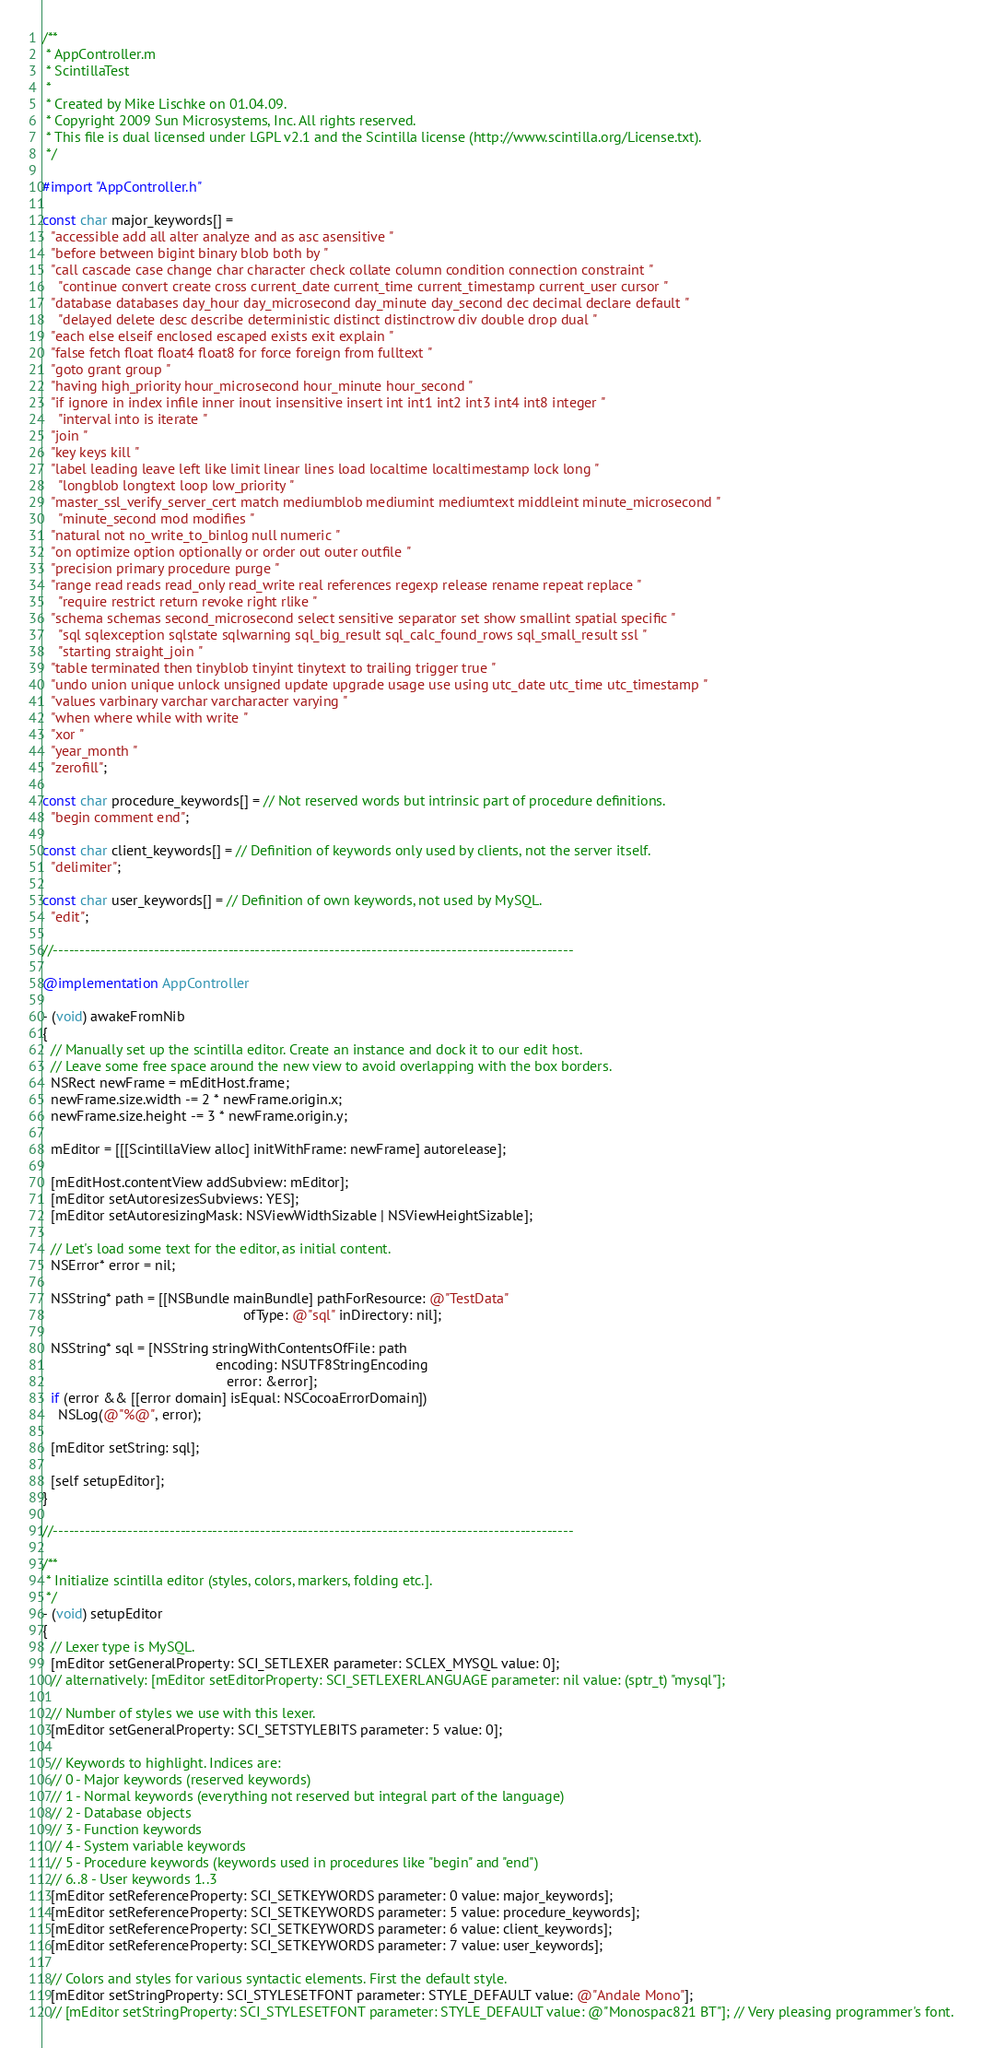Convert code to text. <code><loc_0><loc_0><loc_500><loc_500><_ObjectiveC_>/**
 * AppController.m
 * ScintillaTest
 *
 * Created by Mike Lischke on 01.04.09.
 * Copyright 2009 Sun Microsystems, Inc. All rights reserved.
 * This file is dual licensed under LGPL v2.1 and the Scintilla license (http://www.scintilla.org/License.txt).
 */

#import "AppController.h"

const char major_keywords[] =
  "accessible add all alter analyze and as asc asensitive "
  "before between bigint binary blob both by "
  "call cascade case change char character check collate column condition connection constraint "
    "continue convert create cross current_date current_time current_timestamp current_user cursor "
  "database databases day_hour day_microsecond day_minute day_second dec decimal declare default "
    "delayed delete desc describe deterministic distinct distinctrow div double drop dual "
  "each else elseif enclosed escaped exists exit explain "
  "false fetch float float4 float8 for force foreign from fulltext "
  "goto grant group "
  "having high_priority hour_microsecond hour_minute hour_second "
  "if ignore in index infile inner inout insensitive insert int int1 int2 int3 int4 int8 integer "
    "interval into is iterate "
  "join "
  "key keys kill "
  "label leading leave left like limit linear lines load localtime localtimestamp lock long "
    "longblob longtext loop low_priority "
  "master_ssl_verify_server_cert match mediumblob mediumint mediumtext middleint minute_microsecond "
    "minute_second mod modifies "
  "natural not no_write_to_binlog null numeric "
  "on optimize option optionally or order out outer outfile "
  "precision primary procedure purge "
  "range read reads read_only read_write real references regexp release rename repeat replace "
    "require restrict return revoke right rlike "
  "schema schemas second_microsecond select sensitive separator set show smallint spatial specific "
    "sql sqlexception sqlstate sqlwarning sql_big_result sql_calc_found_rows sql_small_result ssl "
    "starting straight_join "
  "table terminated then tinyblob tinyint tinytext to trailing trigger true "
  "undo union unique unlock unsigned update upgrade usage use using utc_date utc_time utc_timestamp "
  "values varbinary varchar varcharacter varying "
  "when where while with write "
  "xor "
  "year_month "
  "zerofill";

const char procedure_keywords[] = // Not reserved words but intrinsic part of procedure definitions.
  "begin comment end";

const char client_keywords[] = // Definition of keywords only used by clients, not the server itself.
  "delimiter";

const char user_keywords[] = // Definition of own keywords, not used by MySQL.
  "edit";

//--------------------------------------------------------------------------------------------------

@implementation AppController

- (void) awakeFromNib
{
  // Manually set up the scintilla editor. Create an instance and dock it to our edit host.
  // Leave some free space around the new view to avoid overlapping with the box borders.
  NSRect newFrame = mEditHost.frame;
  newFrame.size.width -= 2 * newFrame.origin.x;
  newFrame.size.height -= 3 * newFrame.origin.y;
  
  mEditor = [[[ScintillaView alloc] initWithFrame: newFrame] autorelease];
  
  [mEditHost.contentView addSubview: mEditor];
  [mEditor setAutoresizesSubviews: YES];
  [mEditor setAutoresizingMask: NSViewWidthSizable | NSViewHeightSizable];
  
  // Let's load some text for the editor, as initial content.
  NSError* error = nil;
  
  NSString* path = [[NSBundle mainBundle] pathForResource: @"TestData" 
                                                   ofType: @"sql" inDirectory: nil];
  
  NSString* sql = [NSString stringWithContentsOfFile: path
                                            encoding: NSUTF8StringEncoding
                                               error: &error];
  if (error && [[error domain] isEqual: NSCocoaErrorDomain])
    NSLog(@"%@", error);
  
  [mEditor setString: sql];

  [self setupEditor];
}

//--------------------------------------------------------------------------------------------------

/**
 * Initialize scintilla editor (styles, colors, markers, folding etc.].
 */
- (void) setupEditor
{  
  // Lexer type is MySQL.
  [mEditor setGeneralProperty: SCI_SETLEXER parameter: SCLEX_MYSQL value: 0];
  // alternatively: [mEditor setEditorProperty: SCI_SETLEXERLANGUAGE parameter: nil value: (sptr_t) "mysql"];
  
  // Number of styles we use with this lexer.
  [mEditor setGeneralProperty: SCI_SETSTYLEBITS parameter: 5 value: 0];
  
  // Keywords to highlight. Indices are:
  // 0 - Major keywords (reserved keywords)
  // 1 - Normal keywords (everything not reserved but integral part of the language)
  // 2 - Database objects
  // 3 - Function keywords
  // 4 - System variable keywords
  // 5 - Procedure keywords (keywords used in procedures like "begin" and "end")
  // 6..8 - User keywords 1..3
  [mEditor setReferenceProperty: SCI_SETKEYWORDS parameter: 0 value: major_keywords];
  [mEditor setReferenceProperty: SCI_SETKEYWORDS parameter: 5 value: procedure_keywords];
  [mEditor setReferenceProperty: SCI_SETKEYWORDS parameter: 6 value: client_keywords];
  [mEditor setReferenceProperty: SCI_SETKEYWORDS parameter: 7 value: user_keywords];
  
  // Colors and styles for various syntactic elements. First the default style.
  [mEditor setStringProperty: SCI_STYLESETFONT parameter: STYLE_DEFAULT value: @"Andale Mono"];
  // [mEditor setStringProperty: SCI_STYLESETFONT parameter: STYLE_DEFAULT value: @"Monospac821 BT"]; // Very pleasing programmer's font.</code> 